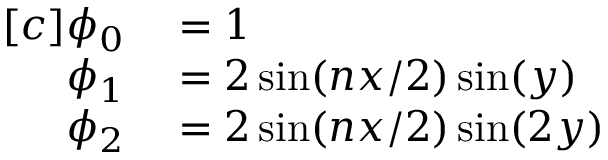Convert formula to latex. <formula><loc_0><loc_0><loc_500><loc_500>\begin{array} { r l } { [ c ] \phi _ { 0 } } & = 1 } \\ { \phi _ { 1 } } & = 2 \sin ( n x / 2 ) \sin ( y ) } \\ { \phi _ { 2 } } & = 2 \sin ( n x / 2 ) \sin ( 2 y ) } \end{array}</formula> 